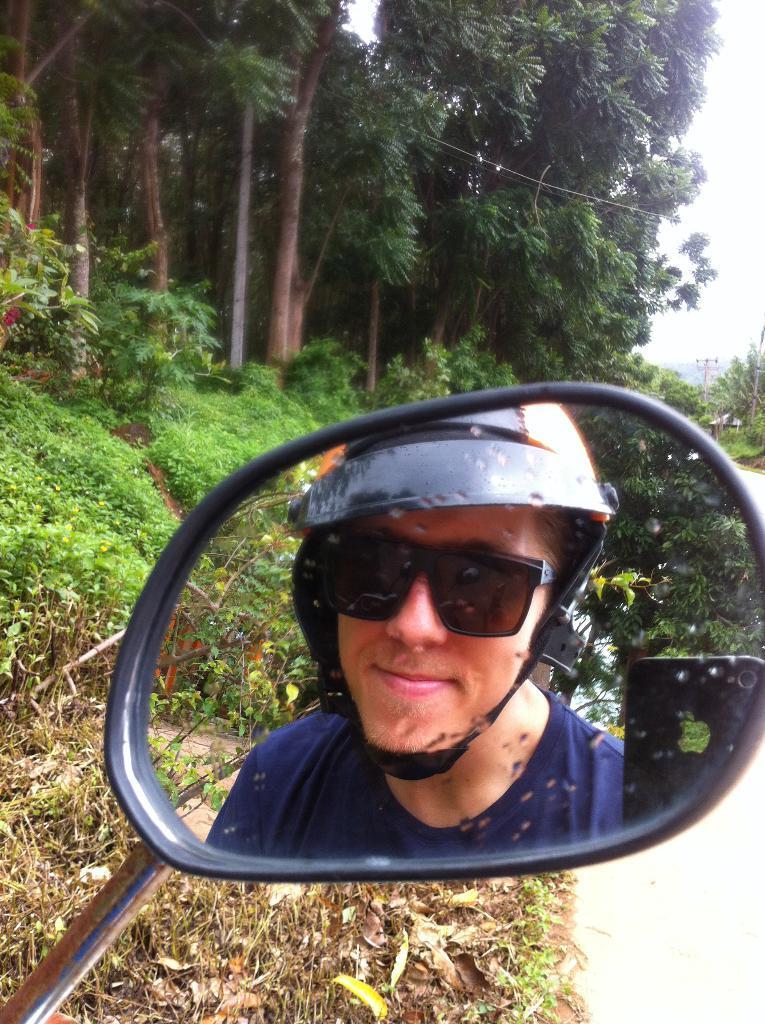Describe this image in one or two sentences. In the center of the image we can see a mirror. In mirror we can see a person is wearing goggles, hat and also we can see a mobile. In the background of the image we can see the trees, plants, dry leaves. On the right side of the image we can see the poles. At the bottom of the image we can see the ground. At the top of the image we can see the sky. 